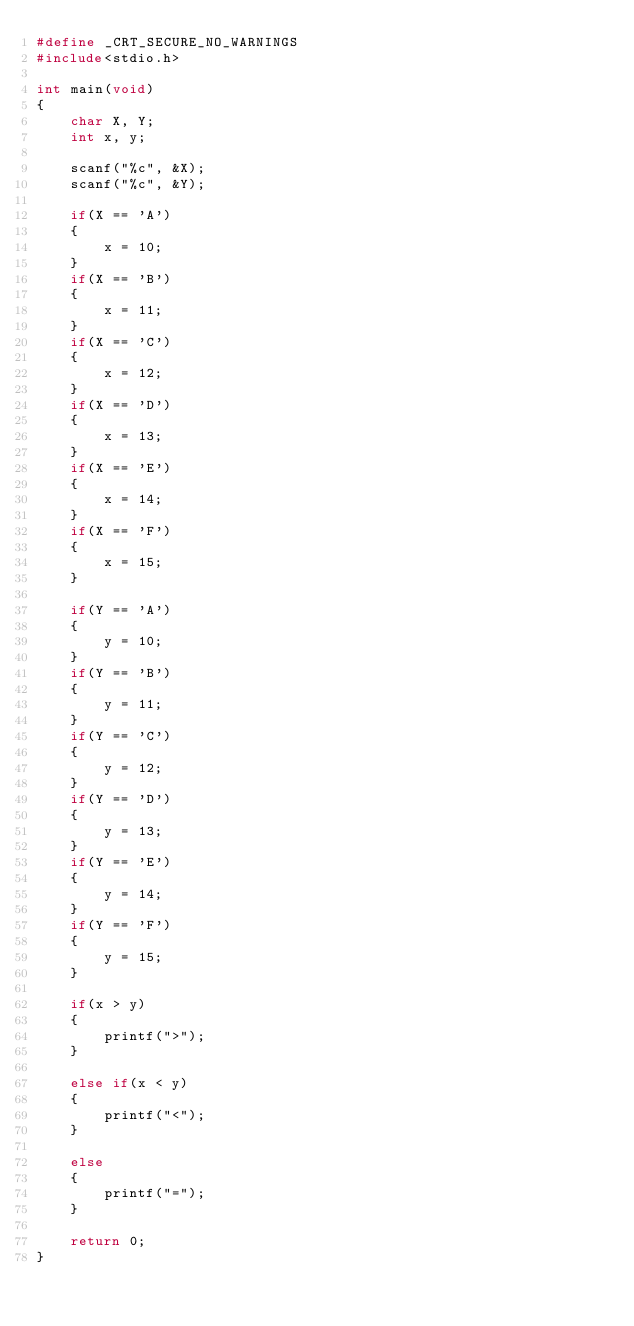Convert code to text. <code><loc_0><loc_0><loc_500><loc_500><_C_>#define _CRT_SECURE_NO_WARNINGS
#include<stdio.h>

int main(void)
{
    char X, Y;
    int x, y;

    scanf("%c", &X);
    scanf("%c", &Y);

    if(X == 'A')
    {
        x = 10;
    }
    if(X == 'B')
    {
        x = 11;
    }
    if(X == 'C')
    {
        x = 12;
    }
    if(X == 'D')
    {
        x = 13;
    }
    if(X == 'E')
    {
        x = 14;
    }
    if(X == 'F')
    {
        x = 15;
    }

    if(Y == 'A')
    {
        y = 10;
    }
    if(Y == 'B')
    {
        y = 11;
    }
    if(Y == 'C')
    {
        y = 12;
    }
    if(Y == 'D')
    {
        y = 13;
    }
    if(Y == 'E')
    {
        y = 14;
    }
    if(Y == 'F')
    {
        y = 15;
    }

    if(x > y)
    {
        printf(">");
    }

    else if(x < y)
    {
        printf("<");
    }

    else
    {
        printf("=");
    }

    return 0;
}</code> 